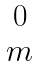Convert formula to latex. <formula><loc_0><loc_0><loc_500><loc_500>\begin{matrix} 0 \\ m \end{matrix}</formula> 